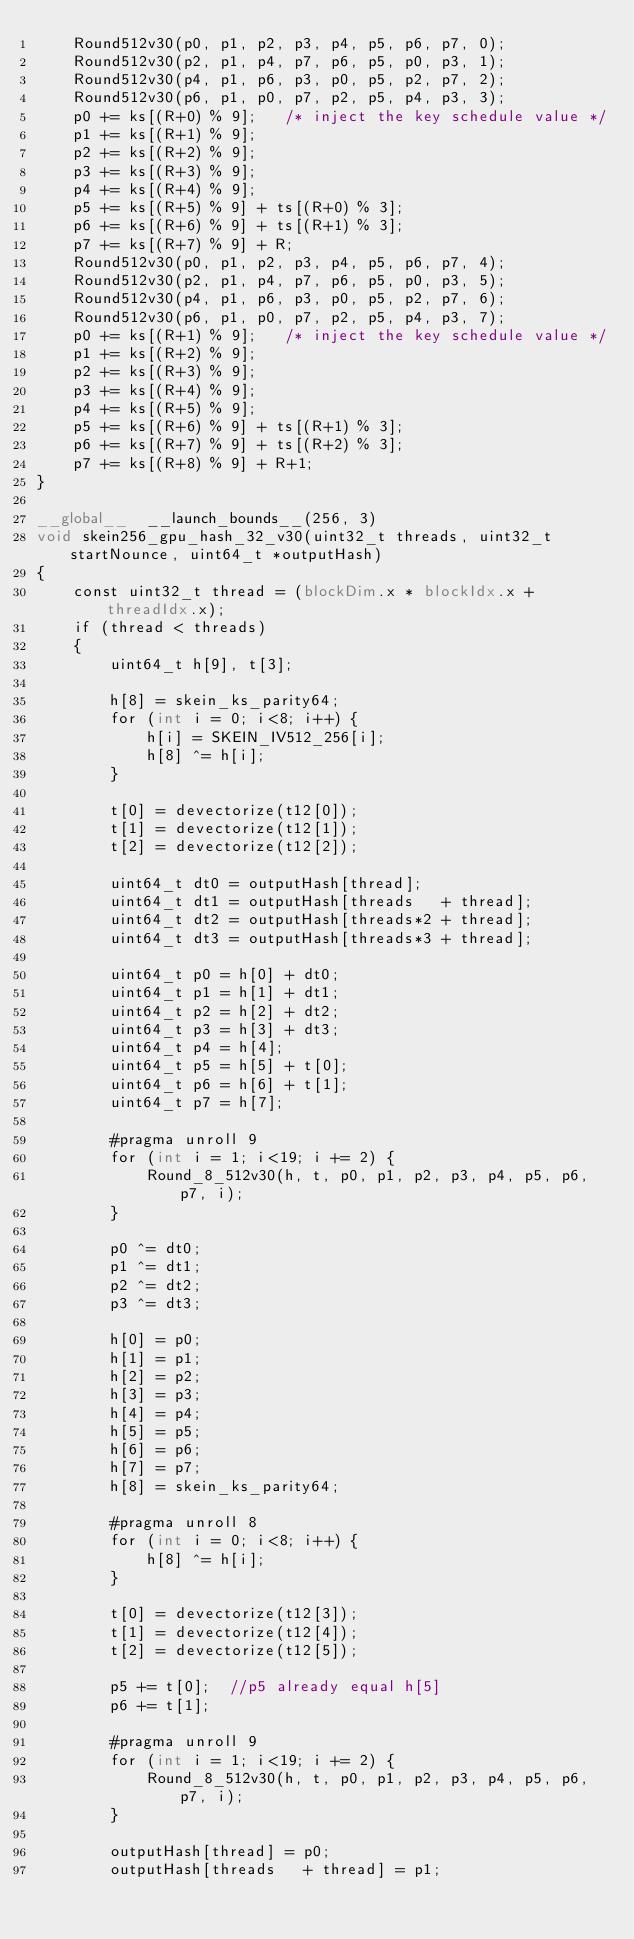Convert code to text. <code><loc_0><loc_0><loc_500><loc_500><_Cuda_>	Round512v30(p0, p1, p2, p3, p4, p5, p6, p7, 0);
	Round512v30(p2, p1, p4, p7, p6, p5, p0, p3, 1);
	Round512v30(p4, p1, p6, p3, p0, p5, p2, p7, 2);
	Round512v30(p6, p1, p0, p7, p2, p5, p4, p3, 3);
	p0 += ks[(R+0) % 9];   /* inject the key schedule value */
	p1 += ks[(R+1) % 9];
	p2 += ks[(R+2) % 9];
	p3 += ks[(R+3) % 9];
	p4 += ks[(R+4) % 9];
	p5 += ks[(R+5) % 9] + ts[(R+0) % 3];
	p6 += ks[(R+6) % 9] + ts[(R+1) % 3];
	p7 += ks[(R+7) % 9] + R;
	Round512v30(p0, p1, p2, p3, p4, p5, p6, p7, 4);
	Round512v30(p2, p1, p4, p7, p6, p5, p0, p3, 5);
	Round512v30(p4, p1, p6, p3, p0, p5, p2, p7, 6);
	Round512v30(p6, p1, p0, p7, p2, p5, p4, p3, 7);
	p0 += ks[(R+1) % 9];   /* inject the key schedule value */
	p1 += ks[(R+2) % 9];
	p2 += ks[(R+3) % 9];
	p3 += ks[(R+4) % 9];
	p4 += ks[(R+5) % 9];
	p5 += ks[(R+6) % 9] + ts[(R+1) % 3];
	p6 += ks[(R+7) % 9] + ts[(R+2) % 3];
	p7 += ks[(R+8) % 9] + R+1;
}

__global__  __launch_bounds__(256, 3)
void skein256_gpu_hash_32_v30(uint32_t threads, uint32_t startNounce, uint64_t *outputHash)
{
	const uint32_t thread = (blockDim.x * blockIdx.x + threadIdx.x);
	if (thread < threads)
	{
		uint64_t h[9], t[3];

		h[8] = skein_ks_parity64;
		for (int i = 0; i<8; i++) {
			h[i] = SKEIN_IV512_256[i];
			h[8] ^= h[i];
		}

		t[0] = devectorize(t12[0]);
		t[1] = devectorize(t12[1]);
		t[2] = devectorize(t12[2]);

		uint64_t dt0 = outputHash[thread];
		uint64_t dt1 = outputHash[threads   + thread];
		uint64_t dt2 = outputHash[threads*2 + thread];
		uint64_t dt3 = outputHash[threads*3 + thread];

		uint64_t p0 = h[0] + dt0;
		uint64_t p1 = h[1] + dt1;
		uint64_t p2 = h[2] + dt2;
		uint64_t p3 = h[3] + dt3;
		uint64_t p4 = h[4];
		uint64_t p5 = h[5] + t[0];
		uint64_t p6 = h[6] + t[1];
		uint64_t p7 = h[7];

		#pragma unroll 9
		for (int i = 1; i<19; i += 2) {
			Round_8_512v30(h, t, p0, p1, p2, p3, p4, p5, p6, p7, i);
		}

		p0 ^= dt0;
		p1 ^= dt1;
		p2 ^= dt2;
		p3 ^= dt3;

		h[0] = p0;
		h[1] = p1;
		h[2] = p2;
		h[3] = p3;
		h[4] = p4;
		h[5] = p5;
		h[6] = p6;
		h[7] = p7;
		h[8] = skein_ks_parity64;

		#pragma unroll 8
		for (int i = 0; i<8; i++) {
			h[8] ^= h[i];
		}

		t[0] = devectorize(t12[3]);
		t[1] = devectorize(t12[4]);
		t[2] = devectorize(t12[5]);

		p5 += t[0];  //p5 already equal h[5]
		p6 += t[1];

		#pragma unroll 9
		for (int i = 1; i<19; i += 2) {
			Round_8_512v30(h, t, p0, p1, p2, p3, p4, p5, p6, p7, i);
		}

		outputHash[thread] = p0;
		outputHash[threads   + thread] = p1;</code> 